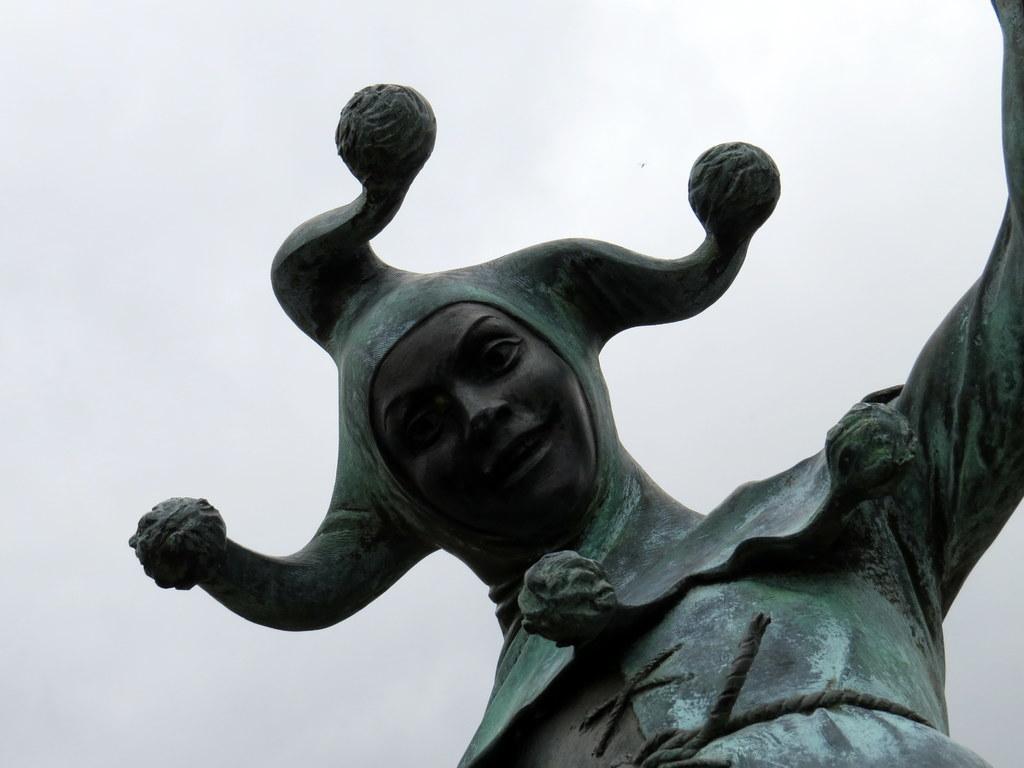How would you summarize this image in a sentence or two? In this picture we can see a sculpture. 